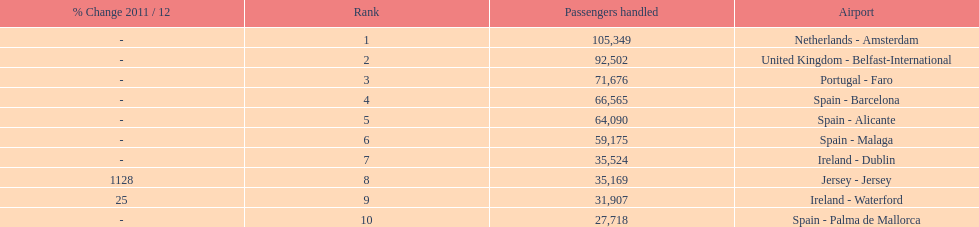Which airport experiences the least passenger flow in connection with london southend airport? Spain - Palma de Mallorca. 